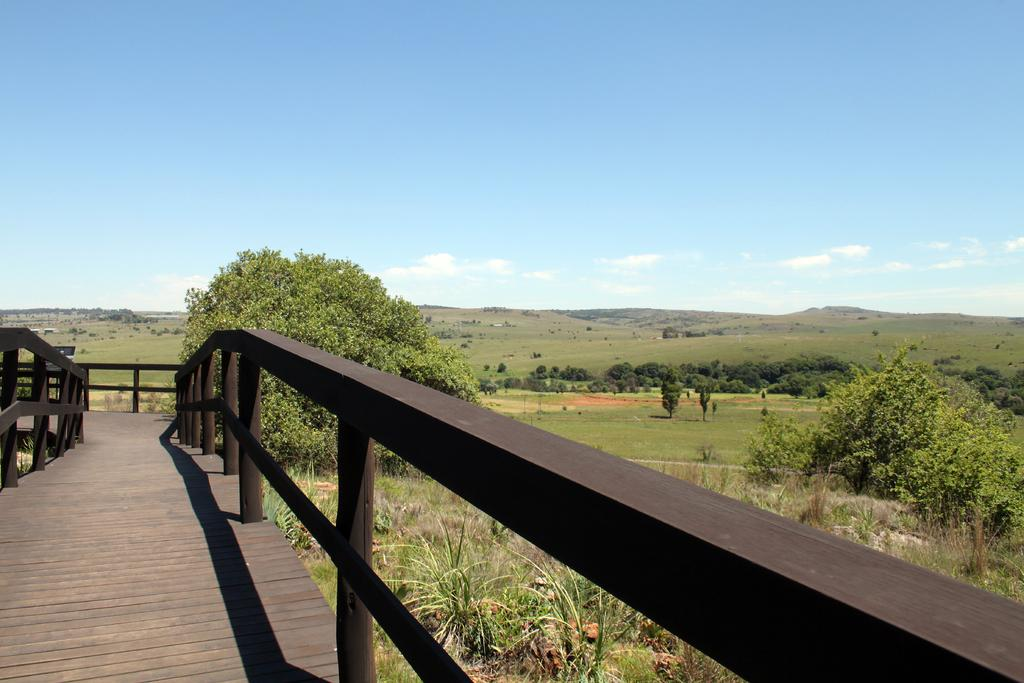What type of barrier can be seen in the image? There is a fence in the image. What can be seen in the distance behind the fence? There are trees and grass in the background of the image. What part of the natural environment is visible in the image? The sky is visible in the background of the image. Can you see a friend holding a wrench in the image? There is no friend or wrench present in the image. 